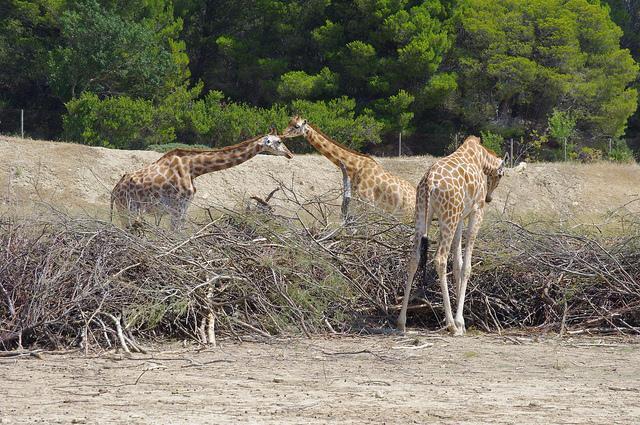How many giraffes are there?
Give a very brief answer. 3. How many animals?
Give a very brief answer. 3. 